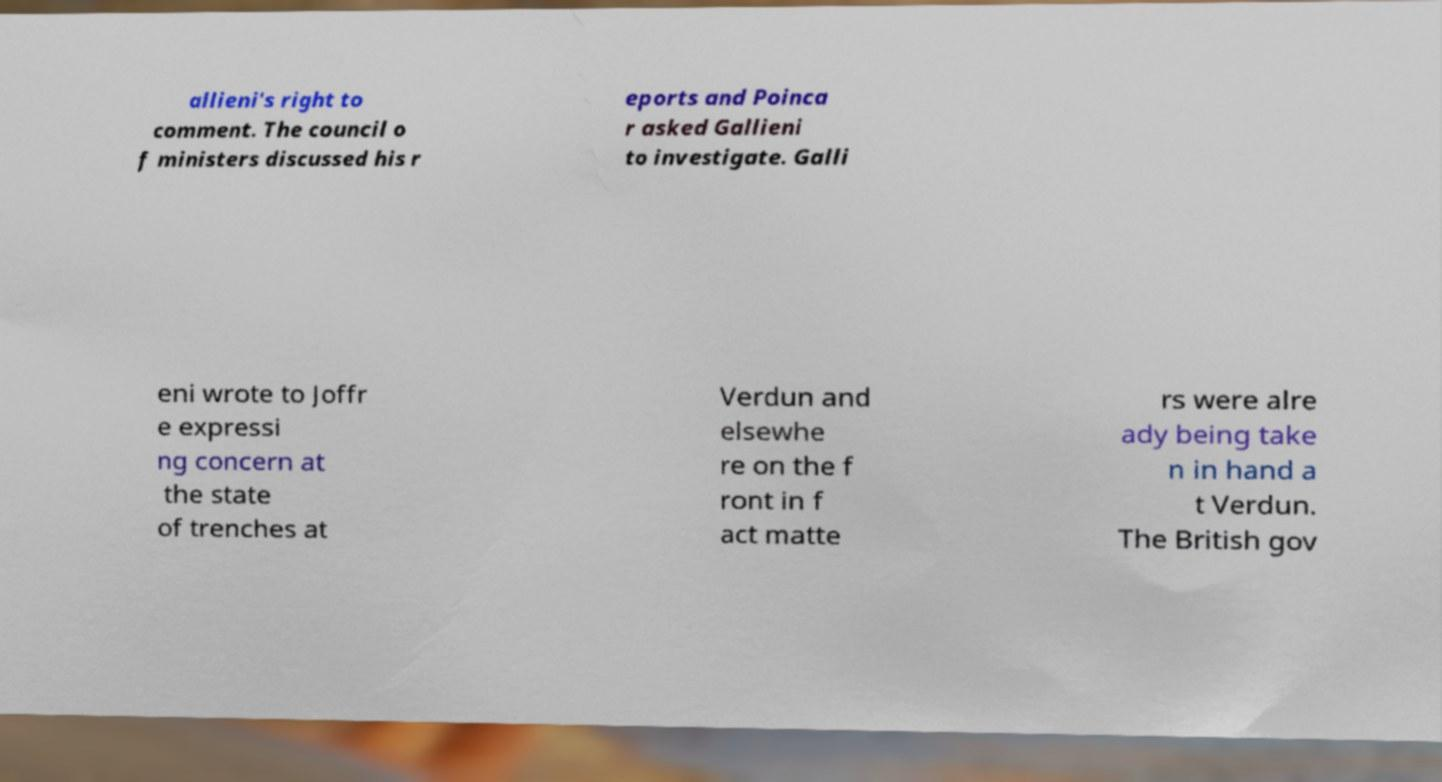Could you assist in decoding the text presented in this image and type it out clearly? allieni's right to comment. The council o f ministers discussed his r eports and Poinca r asked Gallieni to investigate. Galli eni wrote to Joffr e expressi ng concern at the state of trenches at Verdun and elsewhe re on the f ront in f act matte rs were alre ady being take n in hand a t Verdun. The British gov 